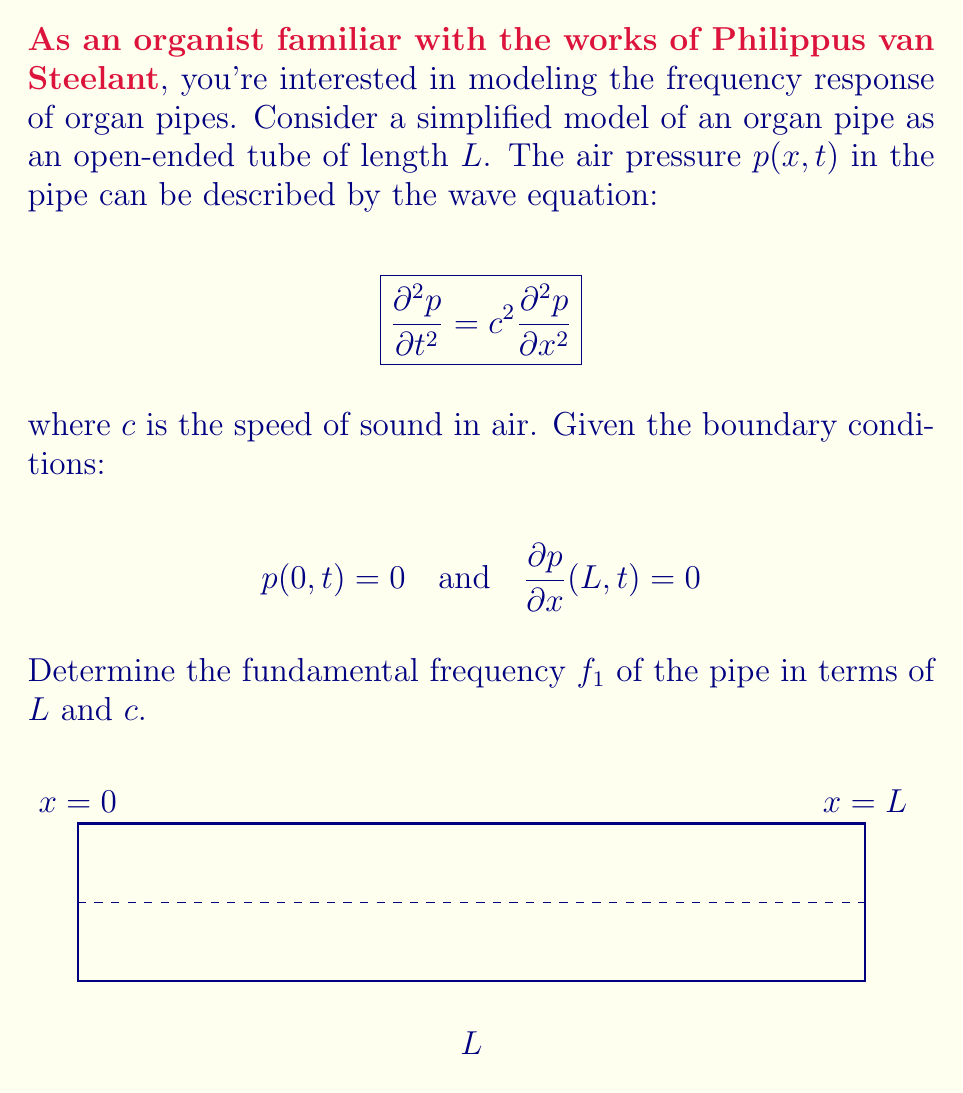Provide a solution to this math problem. To solve this problem, we'll follow these steps:

1) The general solution to the wave equation is of the form:
   $$p(x,t) = [A \cos(kx) + B \sin(kx)][C \cos(\omega t) + D \sin(\omega t)]$$
   where $k$ is the wave number and $\omega$ is the angular frequency.

2) Apply the first boundary condition $p(0,t) = 0$:
   This implies $A = 0$, so our solution becomes:
   $$p(x,t) = B \sin(kx)[C \cos(\omega t) + D \sin(\omega t)]$$

3) Apply the second boundary condition $\frac{\partial p}{\partial x}(L,t) = 0$:
   $$\frac{\partial p}{\partial x} = Bk \cos(kx)[C \cos(\omega t) + D \sin(\omega t)]$$
   At $x = L$, this should be zero, so:
   $$k \cos(kL) = 0$$
   This is satisfied when $kL = \frac{\pi}{2}, \frac{3\pi}{2}, \frac{5\pi}{2}, ...$

4) The fundamental frequency corresponds to the smallest non-zero value of $k$:
   $$k_1 = \frac{\pi}{2L}$$

5) Recall that $\omega = kc$ for waves, so:
   $$\omega_1 = k_1c = \frac{\pi c}{2L}$$

6) Convert angular frequency to regular frequency:
   $$f_1 = \frac{\omega_1}{2\pi} = \frac{c}{4L}$$

Thus, we've derived the fundamental frequency of the open-ended organ pipe.
Answer: $f_1 = \frac{c}{4L}$ 